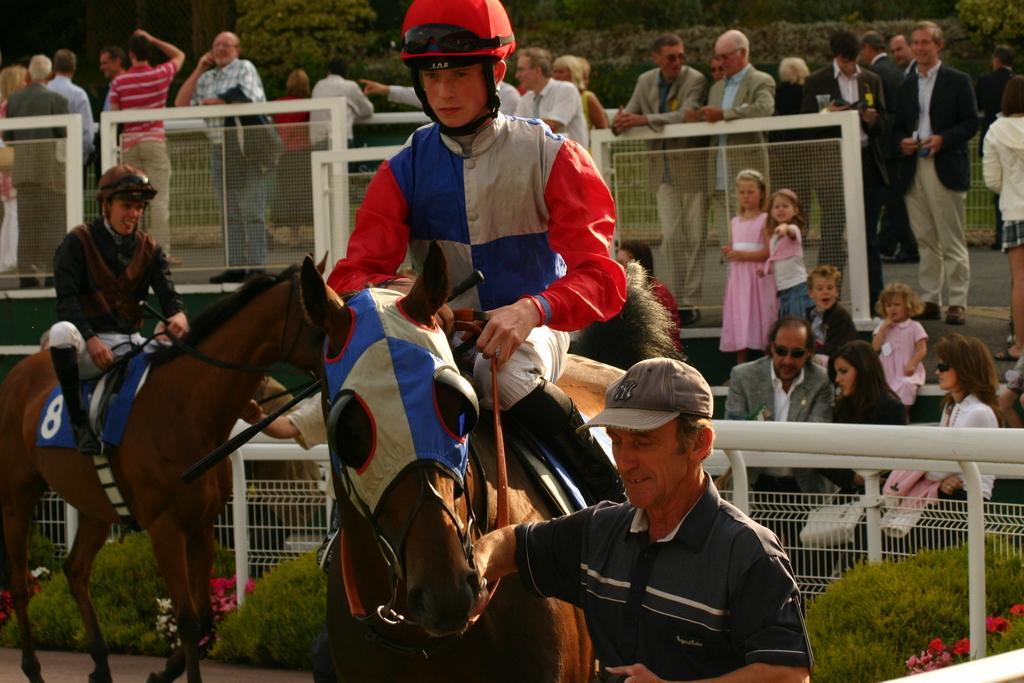Could you give a brief overview of what you see in this image? Here we can see a person sitting on the horse, and here is the person standing, and at back here are the group of people standing. 